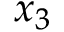Convert formula to latex. <formula><loc_0><loc_0><loc_500><loc_500>x _ { 3 }</formula> 